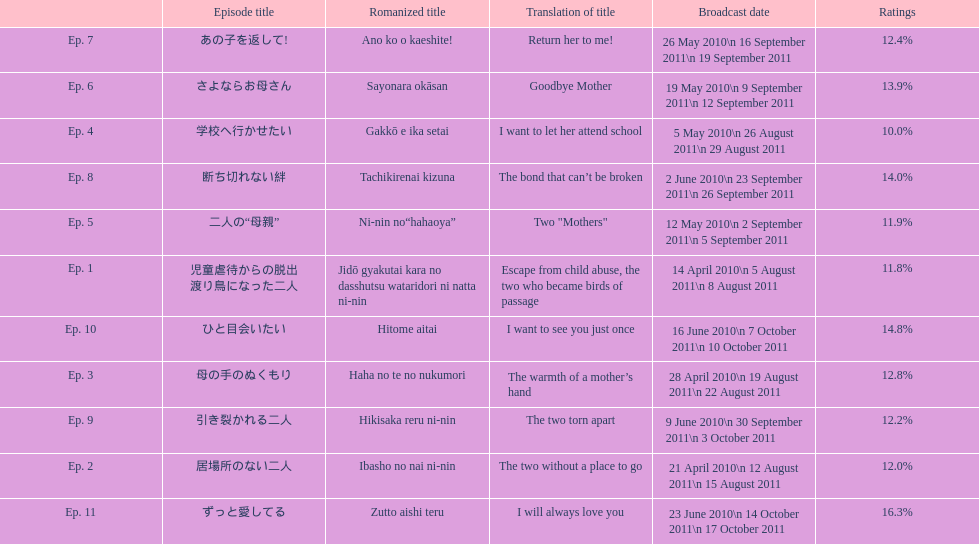What was the name of the next episode after goodbye mother? あの子を返して!. 